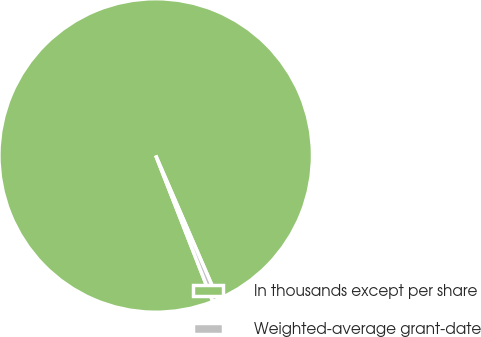Convert chart. <chart><loc_0><loc_0><loc_500><loc_500><pie_chart><fcel>In thousands except per share<fcel>Weighted-average grant-date<nl><fcel>99.42%<fcel>0.58%<nl></chart> 